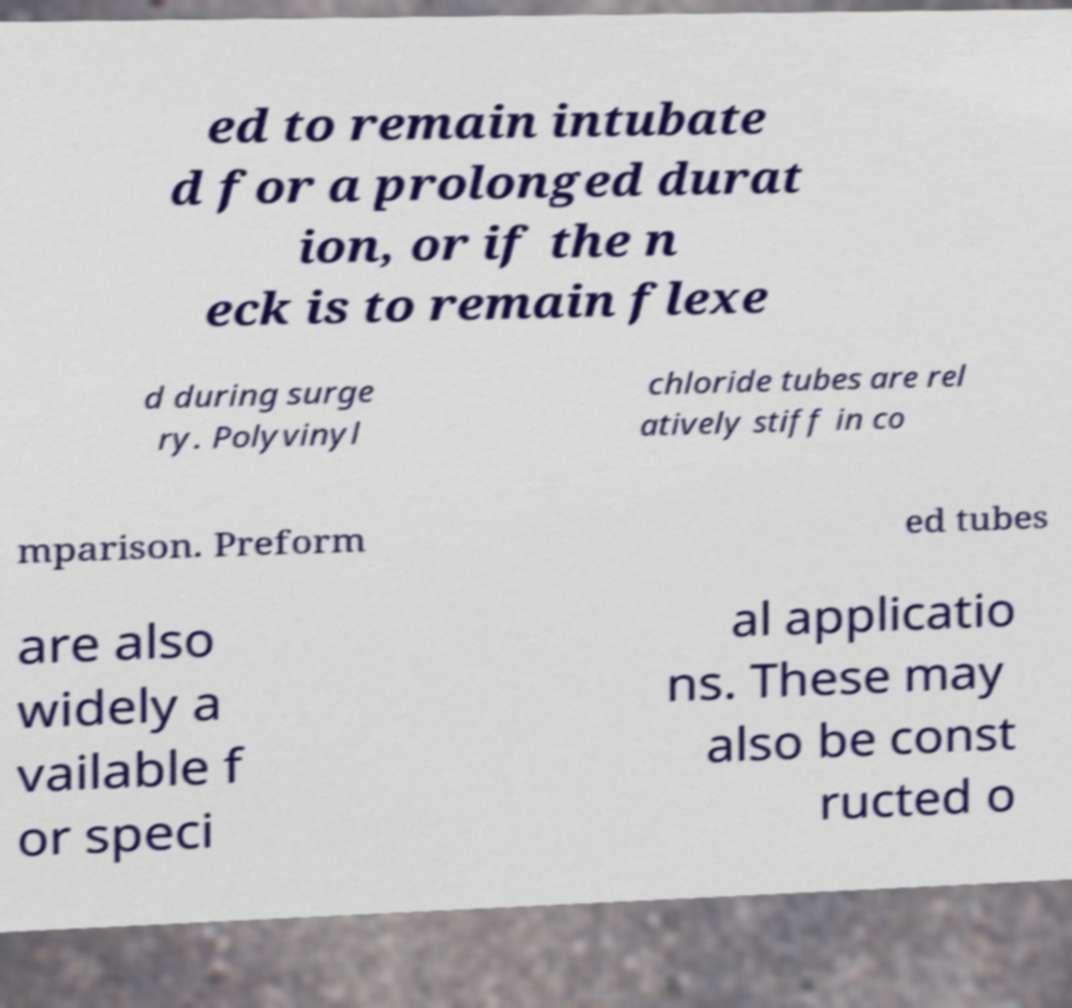There's text embedded in this image that I need extracted. Can you transcribe it verbatim? ed to remain intubate d for a prolonged durat ion, or if the n eck is to remain flexe d during surge ry. Polyvinyl chloride tubes are rel atively stiff in co mparison. Preform ed tubes are also widely a vailable f or speci al applicatio ns. These may also be const ructed o 